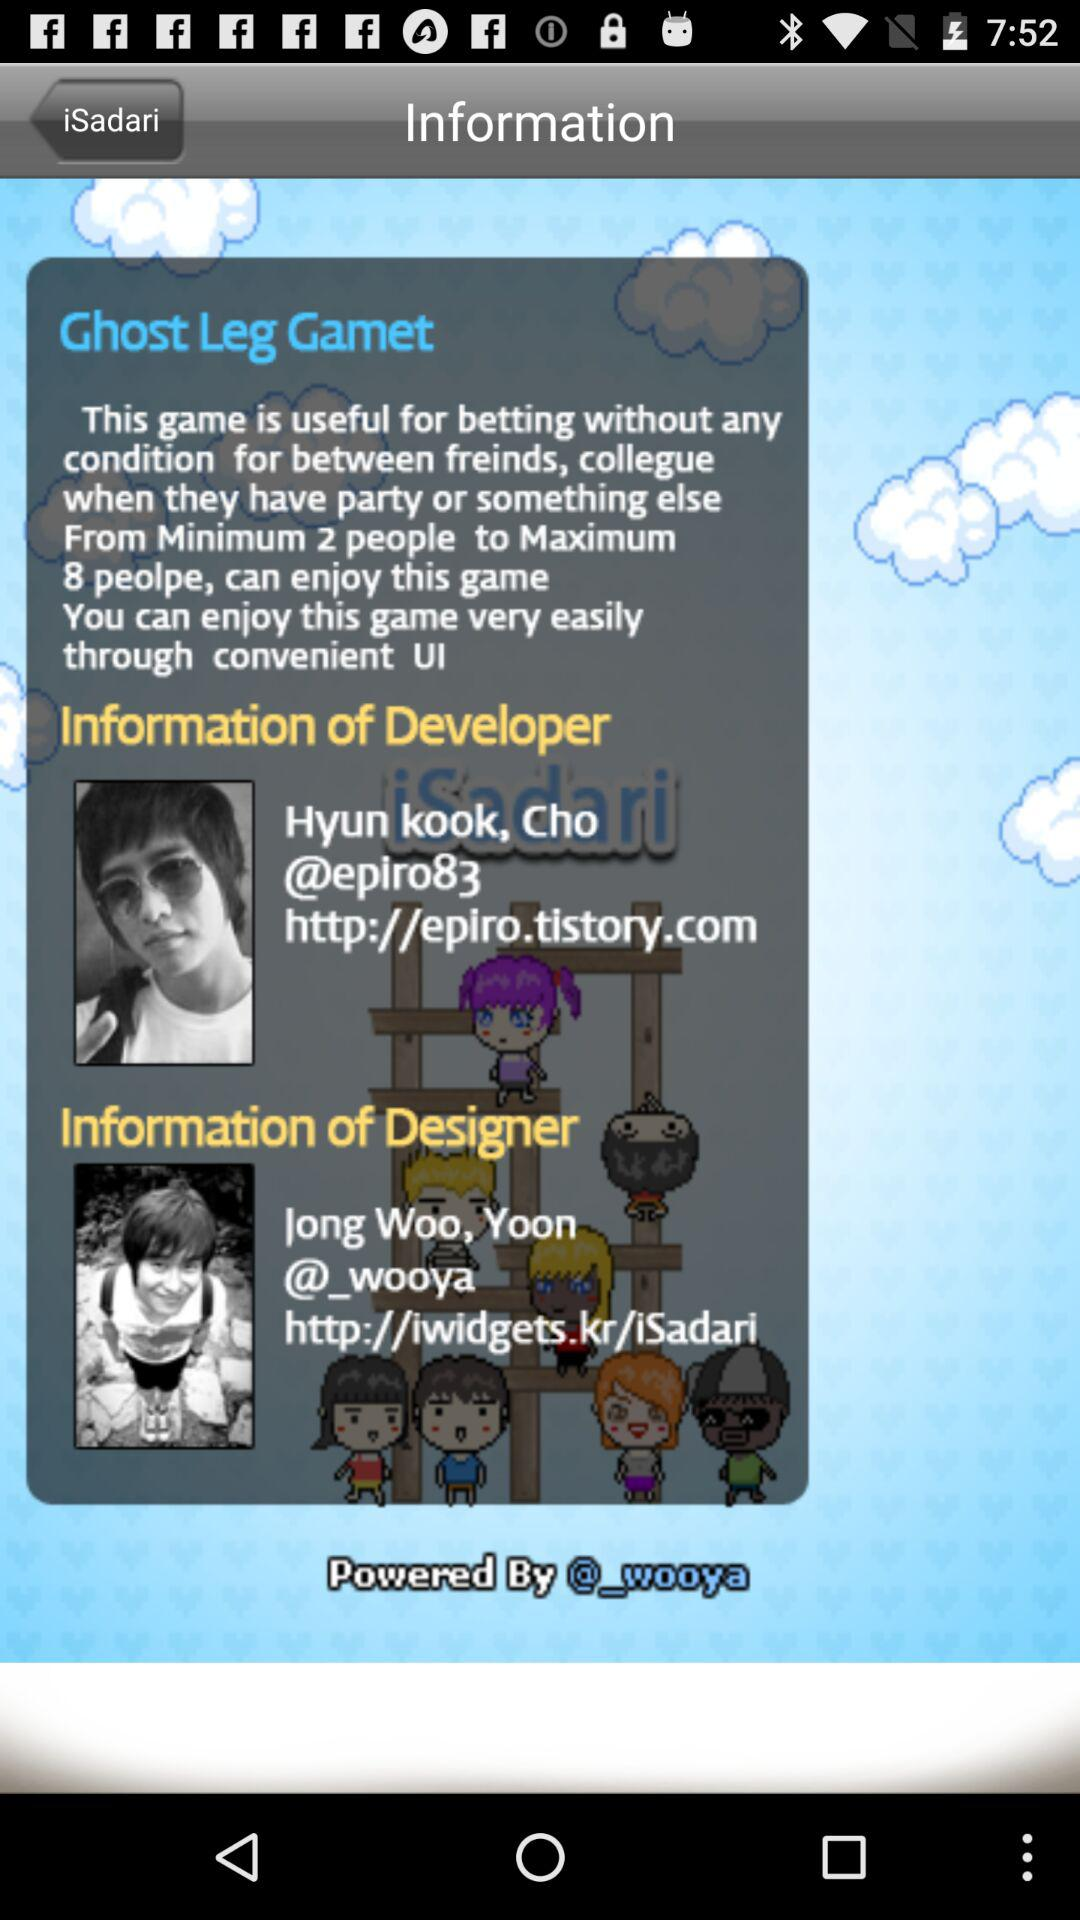What is the name of the game shown? The name of the game is "Ghost Leg Gamet". 